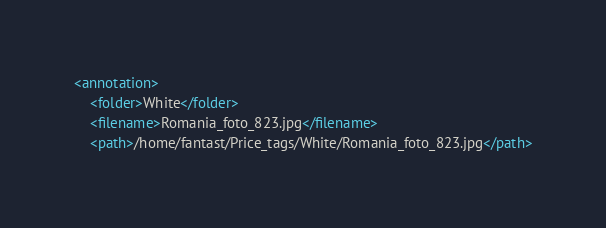Convert code to text. <code><loc_0><loc_0><loc_500><loc_500><_XML_><annotation>
	<folder>White</folder>
	<filename>Romania_foto_823.jpg</filename>
	<path>/home/fantast/Price_tags/White/Romania_foto_823.jpg</path></code> 